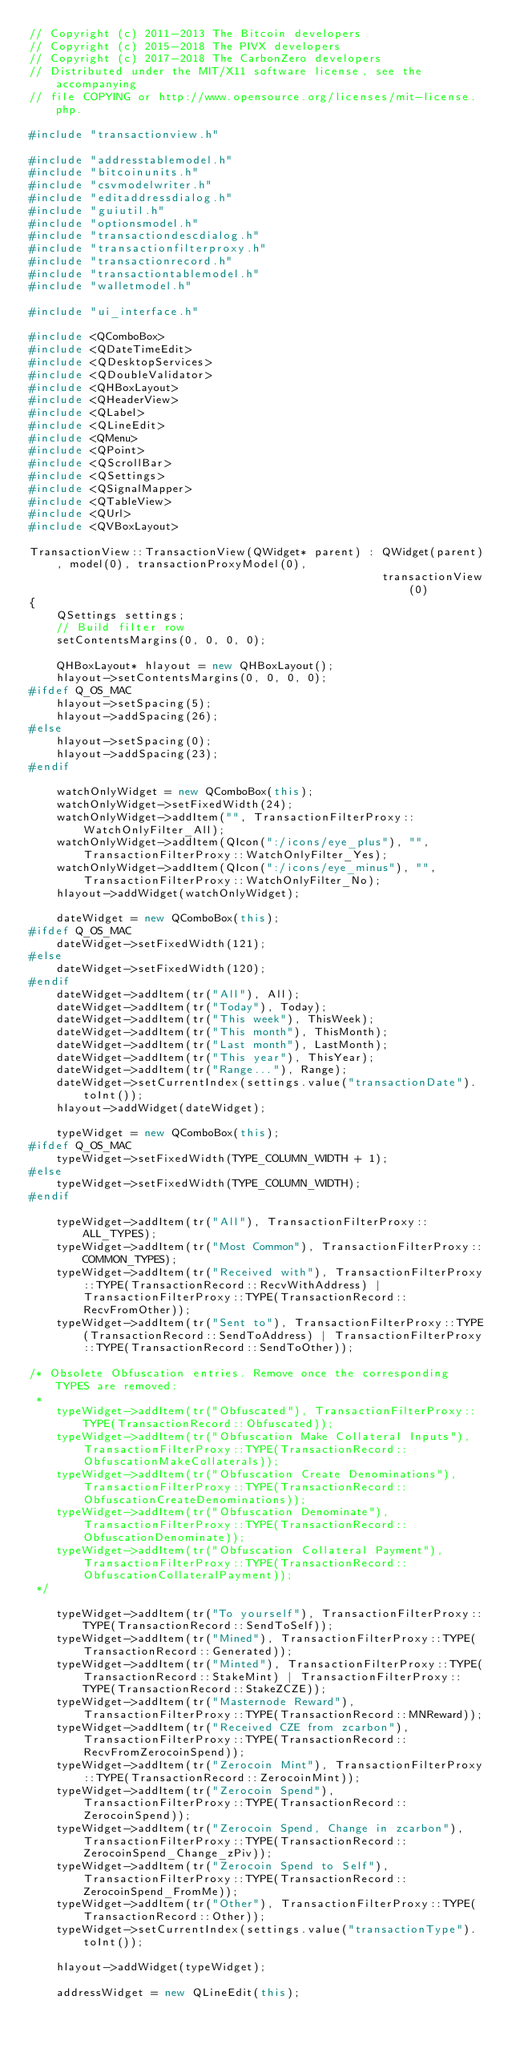Convert code to text. <code><loc_0><loc_0><loc_500><loc_500><_C++_>// Copyright (c) 2011-2013 The Bitcoin developers
// Copyright (c) 2015-2018 The PIVX developers
// Copyright (c) 2017-2018 The CarbonZero developers
// Distributed under the MIT/X11 software license, see the accompanying
// file COPYING or http://www.opensource.org/licenses/mit-license.php.

#include "transactionview.h"

#include "addresstablemodel.h"
#include "bitcoinunits.h"
#include "csvmodelwriter.h"
#include "editaddressdialog.h"
#include "guiutil.h"
#include "optionsmodel.h"
#include "transactiondescdialog.h"
#include "transactionfilterproxy.h"
#include "transactionrecord.h"
#include "transactiontablemodel.h"
#include "walletmodel.h"

#include "ui_interface.h"

#include <QComboBox>
#include <QDateTimeEdit>
#include <QDesktopServices>
#include <QDoubleValidator>
#include <QHBoxLayout>
#include <QHeaderView>
#include <QLabel>
#include <QLineEdit>
#include <QMenu>
#include <QPoint>
#include <QScrollBar>
#include <QSettings>
#include <QSignalMapper>
#include <QTableView>
#include <QUrl>
#include <QVBoxLayout>

TransactionView::TransactionView(QWidget* parent) : QWidget(parent), model(0), transactionProxyModel(0),
                                                    transactionView(0)
{
    QSettings settings;
    // Build filter row
    setContentsMargins(0, 0, 0, 0);

    QHBoxLayout* hlayout = new QHBoxLayout();
    hlayout->setContentsMargins(0, 0, 0, 0);
#ifdef Q_OS_MAC
    hlayout->setSpacing(5);
    hlayout->addSpacing(26);
#else
    hlayout->setSpacing(0);
    hlayout->addSpacing(23);
#endif

    watchOnlyWidget = new QComboBox(this);
    watchOnlyWidget->setFixedWidth(24);
    watchOnlyWidget->addItem("", TransactionFilterProxy::WatchOnlyFilter_All);
    watchOnlyWidget->addItem(QIcon(":/icons/eye_plus"), "", TransactionFilterProxy::WatchOnlyFilter_Yes);
    watchOnlyWidget->addItem(QIcon(":/icons/eye_minus"), "", TransactionFilterProxy::WatchOnlyFilter_No);
    hlayout->addWidget(watchOnlyWidget);

    dateWidget = new QComboBox(this);
#ifdef Q_OS_MAC
    dateWidget->setFixedWidth(121);
#else
    dateWidget->setFixedWidth(120);
#endif
    dateWidget->addItem(tr("All"), All);
    dateWidget->addItem(tr("Today"), Today);
    dateWidget->addItem(tr("This week"), ThisWeek);
    dateWidget->addItem(tr("This month"), ThisMonth);
    dateWidget->addItem(tr("Last month"), LastMonth);
    dateWidget->addItem(tr("This year"), ThisYear);
    dateWidget->addItem(tr("Range..."), Range);
    dateWidget->setCurrentIndex(settings.value("transactionDate").toInt());
    hlayout->addWidget(dateWidget);

    typeWidget = new QComboBox(this);
#ifdef Q_OS_MAC
    typeWidget->setFixedWidth(TYPE_COLUMN_WIDTH + 1);
#else
    typeWidget->setFixedWidth(TYPE_COLUMN_WIDTH);
#endif

    typeWidget->addItem(tr("All"), TransactionFilterProxy::ALL_TYPES);
    typeWidget->addItem(tr("Most Common"), TransactionFilterProxy::COMMON_TYPES);
    typeWidget->addItem(tr("Received with"), TransactionFilterProxy::TYPE(TransactionRecord::RecvWithAddress) | TransactionFilterProxy::TYPE(TransactionRecord::RecvFromOther));
    typeWidget->addItem(tr("Sent to"), TransactionFilterProxy::TYPE(TransactionRecord::SendToAddress) | TransactionFilterProxy::TYPE(TransactionRecord::SendToOther));

/* Obsolete Obfuscation entries. Remove once the corresponding TYPES are removed:
 *
    typeWidget->addItem(tr("Obfuscated"), TransactionFilterProxy::TYPE(TransactionRecord::Obfuscated));
    typeWidget->addItem(tr("Obfuscation Make Collateral Inputs"), TransactionFilterProxy::TYPE(TransactionRecord::ObfuscationMakeCollaterals));
    typeWidget->addItem(tr("Obfuscation Create Denominations"), TransactionFilterProxy::TYPE(TransactionRecord::ObfuscationCreateDenominations));
    typeWidget->addItem(tr("Obfuscation Denominate"), TransactionFilterProxy::TYPE(TransactionRecord::ObfuscationDenominate));
    typeWidget->addItem(tr("Obfuscation Collateral Payment"), TransactionFilterProxy::TYPE(TransactionRecord::ObfuscationCollateralPayment));
 */

    typeWidget->addItem(tr("To yourself"), TransactionFilterProxy::TYPE(TransactionRecord::SendToSelf));
    typeWidget->addItem(tr("Mined"), TransactionFilterProxy::TYPE(TransactionRecord::Generated));
    typeWidget->addItem(tr("Minted"), TransactionFilterProxy::TYPE(TransactionRecord::StakeMint) | TransactionFilterProxy::TYPE(TransactionRecord::StakeZCZE));
    typeWidget->addItem(tr("Masternode Reward"), TransactionFilterProxy::TYPE(TransactionRecord::MNReward));
    typeWidget->addItem(tr("Received CZE from zcarbon"), TransactionFilterProxy::TYPE(TransactionRecord::RecvFromZerocoinSpend));
    typeWidget->addItem(tr("Zerocoin Mint"), TransactionFilterProxy::TYPE(TransactionRecord::ZerocoinMint));
    typeWidget->addItem(tr("Zerocoin Spend"), TransactionFilterProxy::TYPE(TransactionRecord::ZerocoinSpend));
    typeWidget->addItem(tr("Zerocoin Spend, Change in zcarbon"), TransactionFilterProxy::TYPE(TransactionRecord::ZerocoinSpend_Change_zPiv));
    typeWidget->addItem(tr("Zerocoin Spend to Self"), TransactionFilterProxy::TYPE(TransactionRecord::ZerocoinSpend_FromMe));
    typeWidget->addItem(tr("Other"), TransactionFilterProxy::TYPE(TransactionRecord::Other));
    typeWidget->setCurrentIndex(settings.value("transactionType").toInt());

    hlayout->addWidget(typeWidget);

    addressWidget = new QLineEdit(this);</code> 